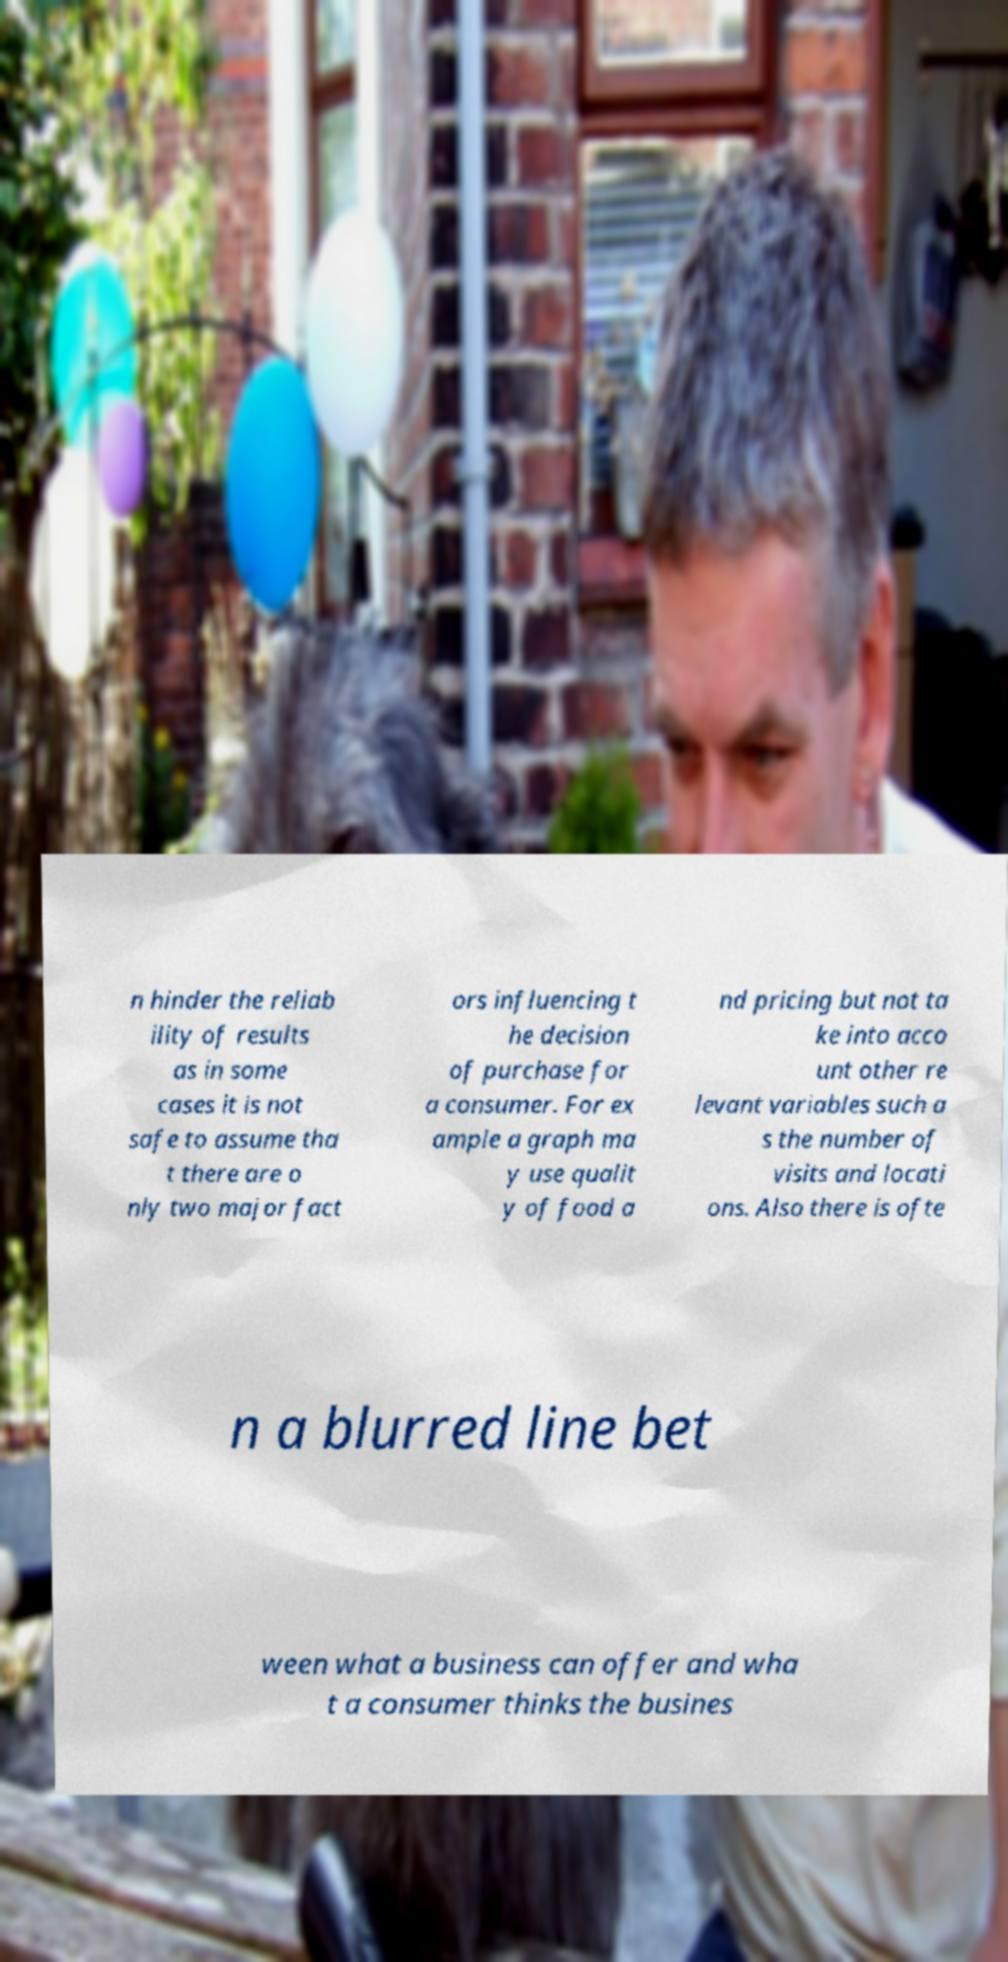There's text embedded in this image that I need extracted. Can you transcribe it verbatim? n hinder the reliab ility of results as in some cases it is not safe to assume tha t there are o nly two major fact ors influencing t he decision of purchase for a consumer. For ex ample a graph ma y use qualit y of food a nd pricing but not ta ke into acco unt other re levant variables such a s the number of visits and locati ons. Also there is ofte n a blurred line bet ween what a business can offer and wha t a consumer thinks the busines 